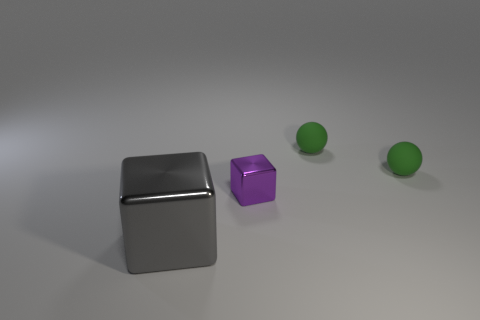Add 4 green blocks. How many objects exist? 8 Subtract all gray cubes. How many cubes are left? 1 Subtract 2 blocks. How many blocks are left? 0 Subtract all brown matte cylinders. Subtract all balls. How many objects are left? 2 Add 4 small green rubber things. How many small green rubber things are left? 6 Add 4 small yellow metallic spheres. How many small yellow metallic spheres exist? 4 Subtract 1 gray cubes. How many objects are left? 3 Subtract all green blocks. Subtract all red cylinders. How many blocks are left? 2 Subtract all blue cylinders. How many purple cubes are left? 1 